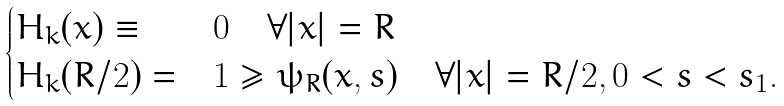<formula> <loc_0><loc_0><loc_500><loc_500>\begin{cases} H _ { k } ( x ) \equiv & 0 \quad \forall | x | = R \\ H _ { k } ( R / 2 ) = & 1 \geq \psi _ { R } ( x , s ) \quad \forall | x | = R / 2 , 0 < s < s _ { 1 } . \end{cases}</formula> 